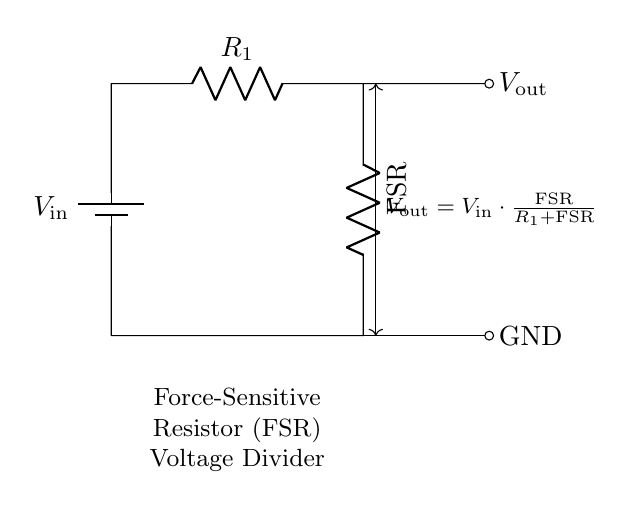What is the input voltage in the circuit? The input voltage, denoted as V_in, represents the voltage supplied to the circuit, specifically shown next to the battery component.
Answer: V_in What type of resistor is used in this circuit? The circuit contains a force-sensitive resistor (FSR) indicated by the label next to the resistor symbol, which is designed to change resistance based on applied force.
Answer: FSR What is the equation for V_out in this circuit? The equation for V_out in this voltage divider is shown in the circuit diagram, correlating output voltage to both V_in and the resistances involved.
Answer: V_out = V_in * FSR / (R1 + FSR) Where does V_out connect in the circuit? V_out is connected to the right side of the FSR and leads out of the circuit, as depicted by the arrow pointing away from the component.
Answer: Right side of FSR How does the resistance R_1 affect V_out? R_1 affects V_out by working in conjunction with the FSR; as R_1 increases, it increases the total resistance in the denominator of the output voltage equation, thus reducing V_out for a given V_in.
Answer: Reduces V_out What happens to V_out if the FSR is squeezed? Squeezing the FSR decreases its resistance, which increases the value of V_out according to the voltage divider equation since the total resistance in the denominator becomes smaller.
Answer: Increases V_out 